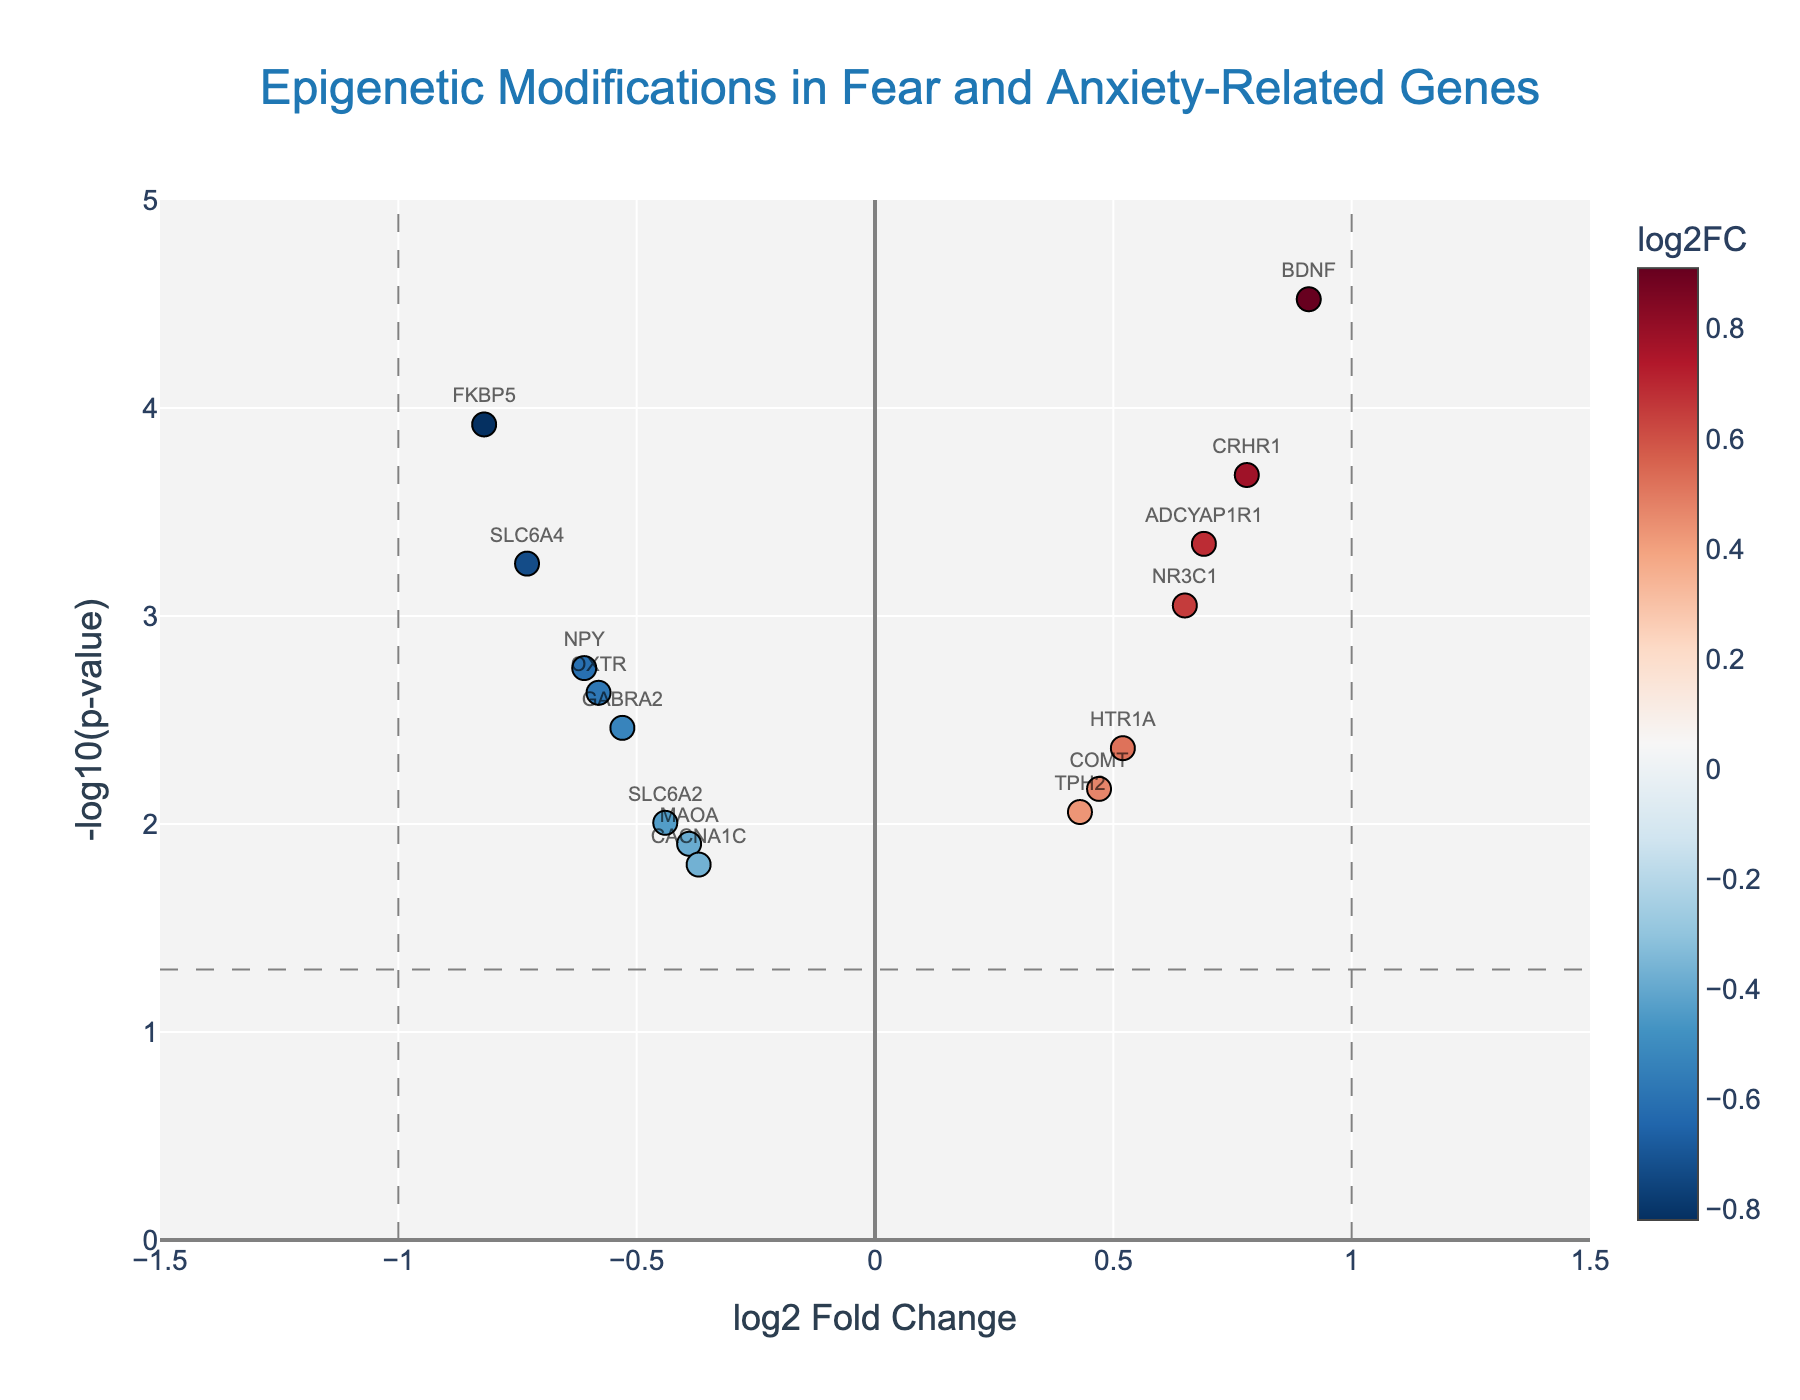What is the title of the plot? The title is usually displayed at the top of the plot. In this case, the title reads: 'Epigenetic Modifications in Fear and Anxiety-Related Genes'.
Answer: Epigenetic Modifications in Fear and Anxiety-Related Genes What is the x-axis label? The x-axis label explains what is displayed along the horizontal axis. It says 'log2 Fold Change'.
Answer: log2 Fold Change Which gene has the smallest p-value and what does it indicate? To find the smallest p-value, look for the highest point on the y-axis (since it's -log10(p-value)). The gene 'BDNF' has the smallest p-value (highest y-value) at about 4.52, indicating the strongest statistical significance.
Answer: BDNF How many genes show significant downregulation (log2FoldChange < -1)? To count the significant downregulated genes, identify points left of x = -1. This includes genes plotted with log2FoldChange < -1. No points fall left of x = -1 line in the given data.
Answer: 0 Which gene shows the highest positive change in expression, and by how much? To determine the highest positive expression change, find the rightmost point. 'BDNF' has the highest log2FoldChange at 0.91.
Answer: BDNF, 0.91 What is the approximate p-value for the gene FKBP5? Identify the point for FKBP5. Its y-value is about 3.92, translating to a p-value of approximately 0.0001.
Answer: 0.0001 How many genes have p-values less than 0.01? Count points above the y = -log10(0.01) line (since -log10(0.01) = 2). There are ten such genes.
Answer: 10 Which gene has the highest negative log2FoldChange, and by how much? Identify the leftmost point. 'SLC6A4' has the most negative log2FoldChange at -0.73.
Answer: SLC6A4, -0.73 Are there more upregulated or downregulated genes with a p-value < 0.01? Upregulated (log2FoldChange > 0) and downregulated (log2FoldChange < 0) genes with p-values < 0.01 can be compared. There are five upregulated (BDNF, CRHR1, NR3C1, ADCYAP1R1, HTR1A) and five downregulated (FKBP5, SLC6A4, NPY, OXTR, GABRA2).
Answer: Equal What are the axes ranges for this plot? The ranges are visible along the axes. The x-axis ranges from -1.5 to 1.5, and the y-axis ranges from 0 to 5.
Answer: x: -1.5 to 1.5, y: 0 to 5 